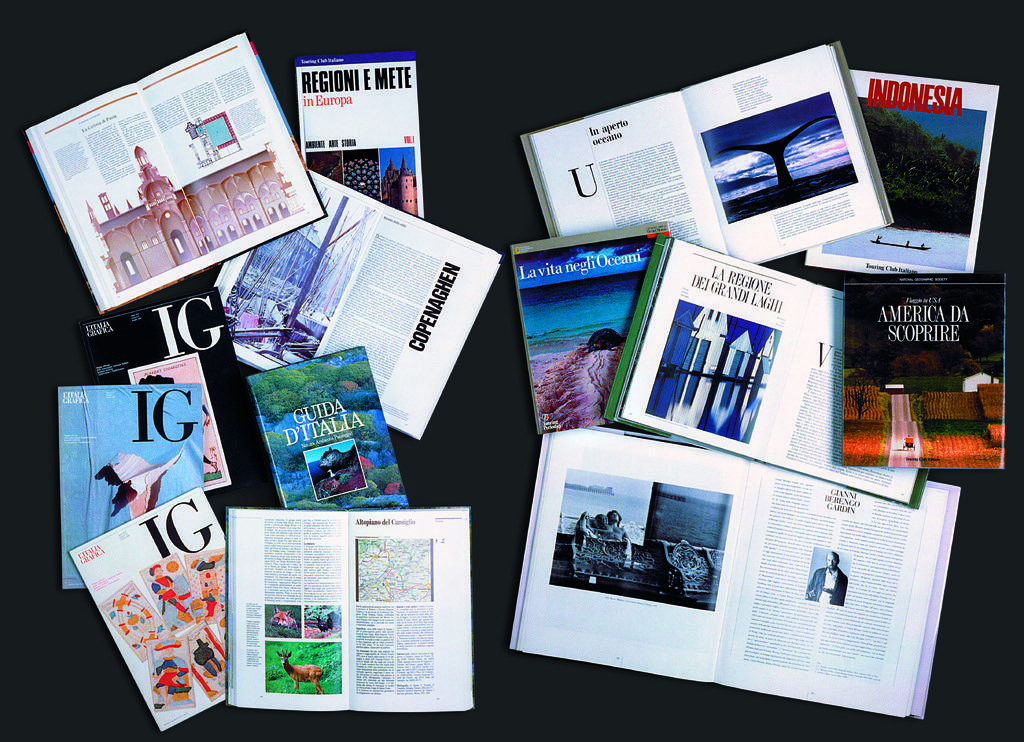What is the name of the magazine in the left hand corner?
Ensure brevity in your answer.  Ig. What city is mentioned on one of the magazines?
Your answer should be compact. Copenhagen. 